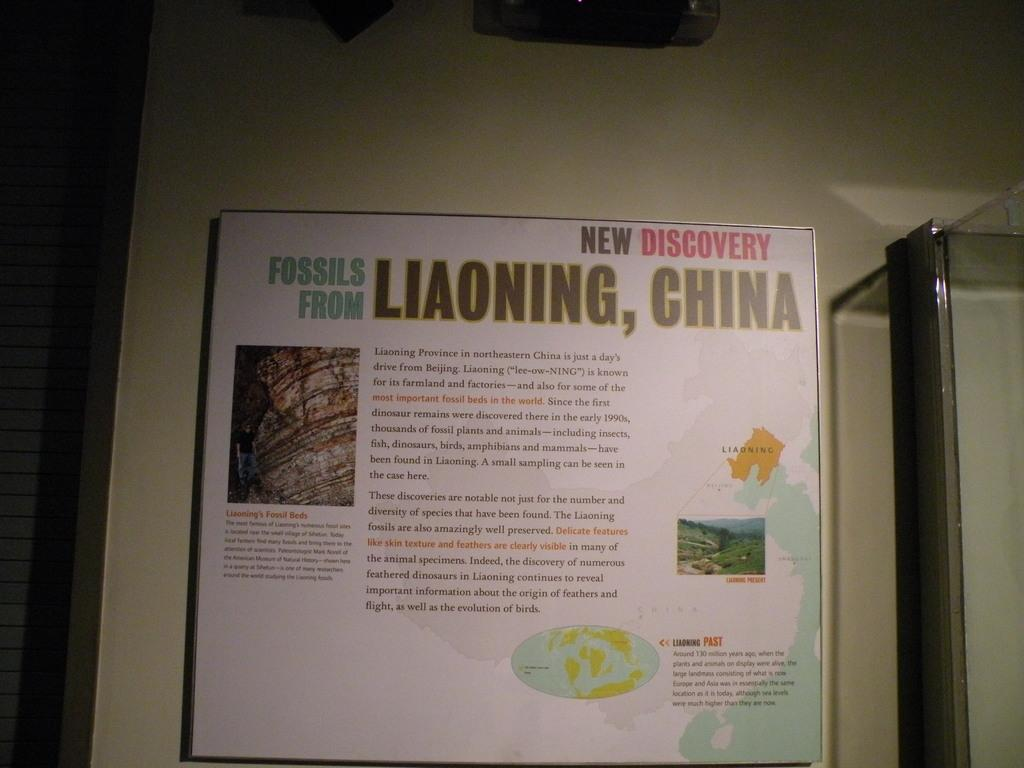What is attached to the wall in the image? There is a board attached to the wall in the image. What material is the glass made of in the image? The glass is made of transparent material, allowing us to see through it. Can you describe any other objects present in the image? Unfortunately, the provided facts do not give specific details about other objects in the image. How many roots can be seen growing from the board in the image? There are no roots visible in the image; it features a board attached to the wall. What type of rings are being worn by the people in the image? There are no people present in the image, so it is impossible to determine if anyone is wearing rings. 